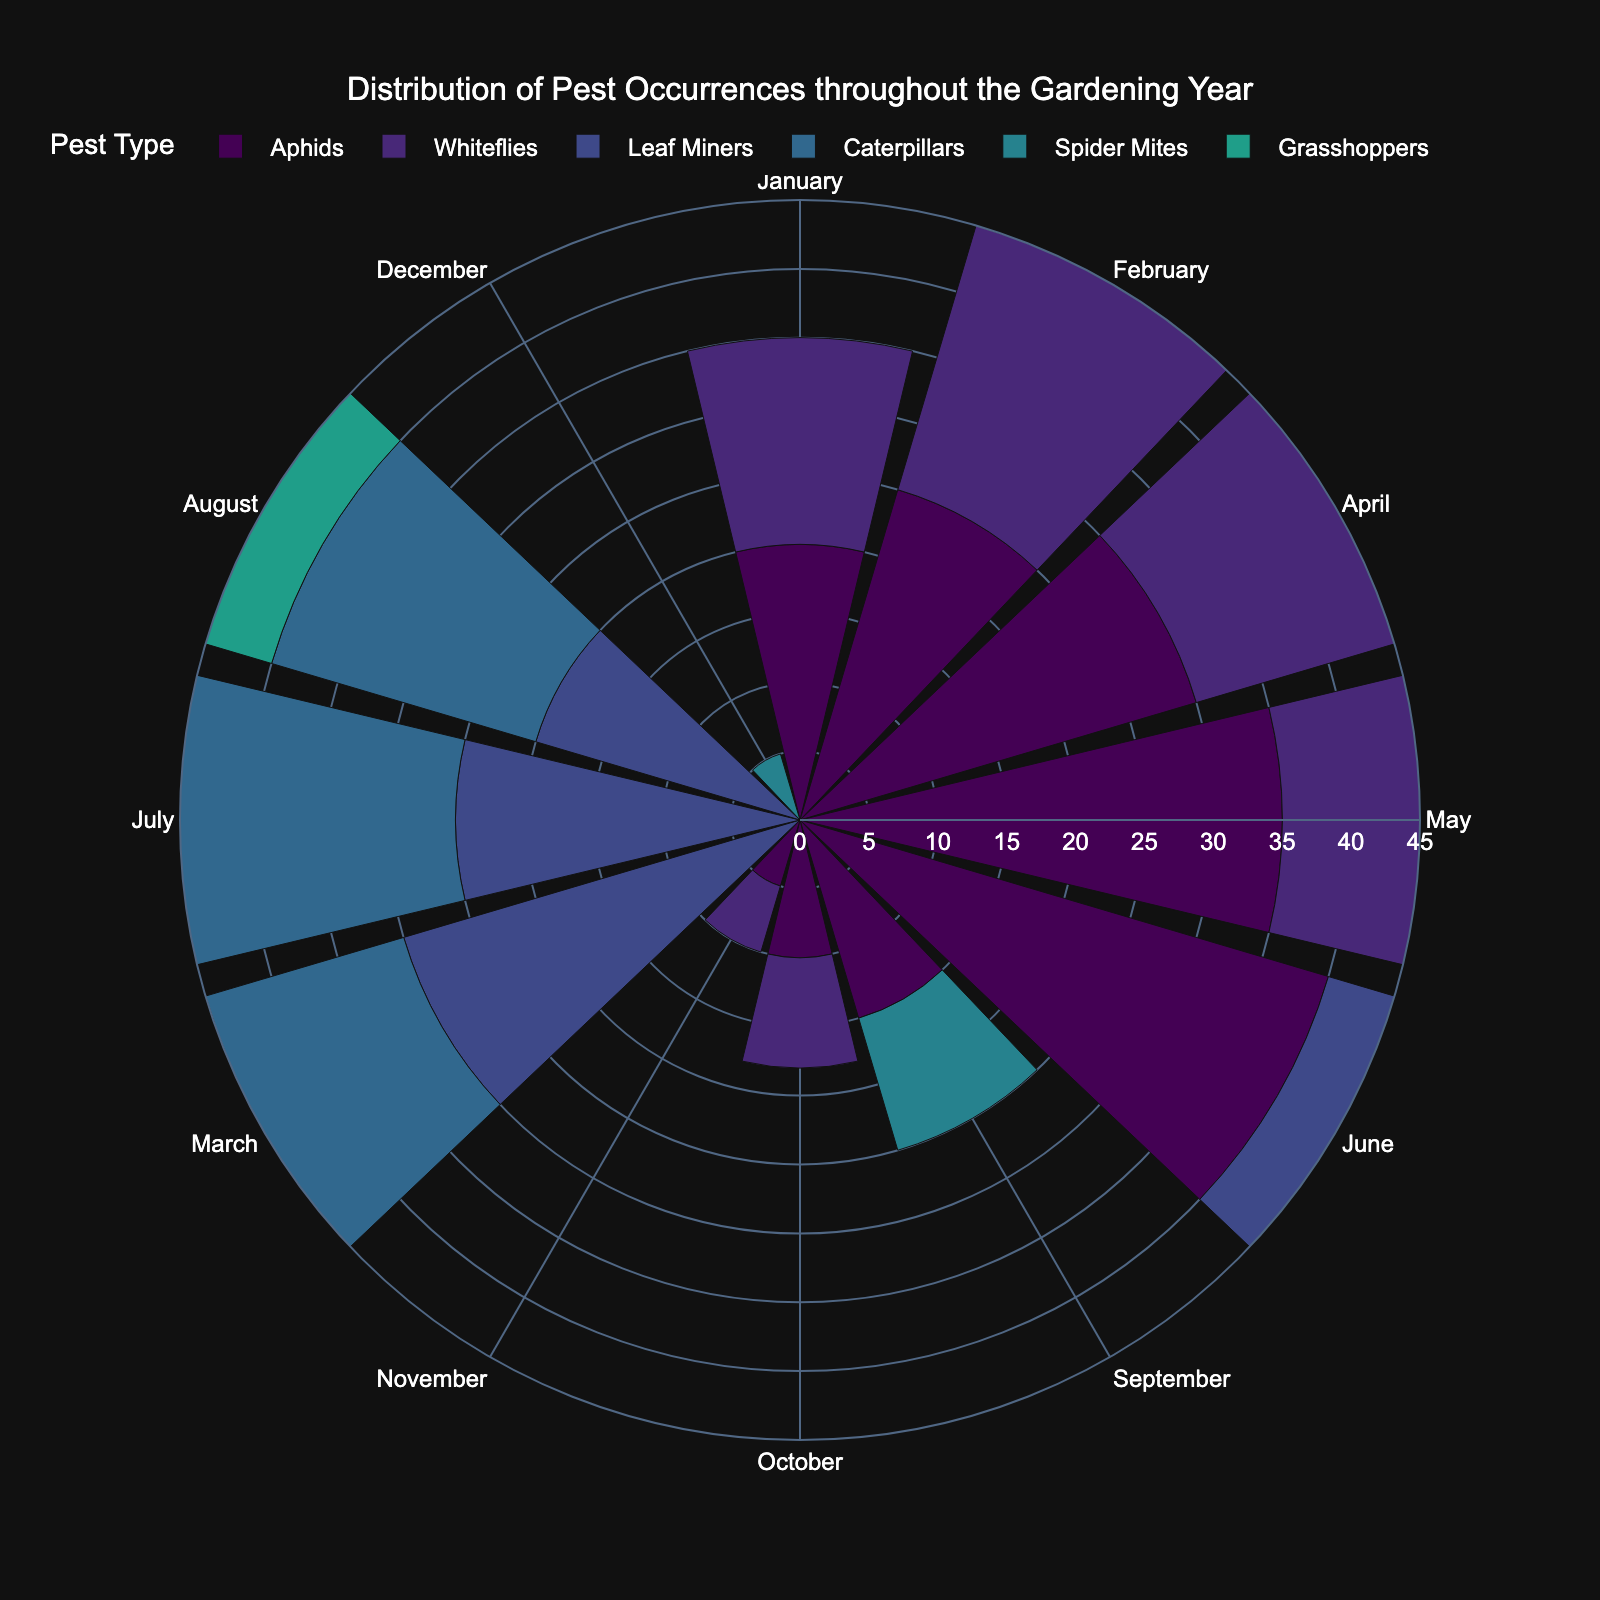What is the title of the chart? The title of the chart is displayed prominently at the top and reads "Distribution of Pest Occurrences throughout the Gardening Year."
Answer: Distribution of Pest Occurrences throughout the Gardening Year Which month has the highest occurrence of Aphids? From the rose chart, the longest bar representing Aphids peaks in June.
Answer: June Compare the occurrences of Whiteflies in April and May. Which month has more occurrences? To compare, look at the length of the bars for Whiteflies in April and May. The bar for May is longer, indicating more occurrences in May.
Answer: May What is the difference in occurrences between Aphids in June and October? From the chart, Aphids have 40 occurrences in June and 10 occurrences in October. The difference is calculated as 40 - 10.
Answer: 30 Sum the total occurrences of Aphids from January to May. Look at the occurrences for Aphids from January (20), February (25), March (0), April (30), and May (35). Summing these values gives 20 + 25 + 0 + 30 + 35 = 110.
Answer: 110 Which pest appears the most frequently in July? Inspect the lengths of the bars in July for each pest. The bar for Caterpillars is the longest.
Answer: Caterpillars During which month do Spider Mites have their highest occurrence? The rose chart shows the longest bar for Spider Mites in June.
Answer: June Are Grasshoppers present in all months of the year? By checking each segment of the rose chart, Grasshoppers are only present in July and August.
Answer: No Which month has the lowest occurrence of pests overall? Evaluate the sum of all pest occurrences for each month. The month with the smallest overall height (January) has the lowest total occurrences.
Answer: December What is the median occurrence value for pests in April? The occurrence values in April are 30 (Aphids), 20 (Whiteflies), and 10 (Spider Mites). The median value is the middle number, which is 20.
Answer: 20 